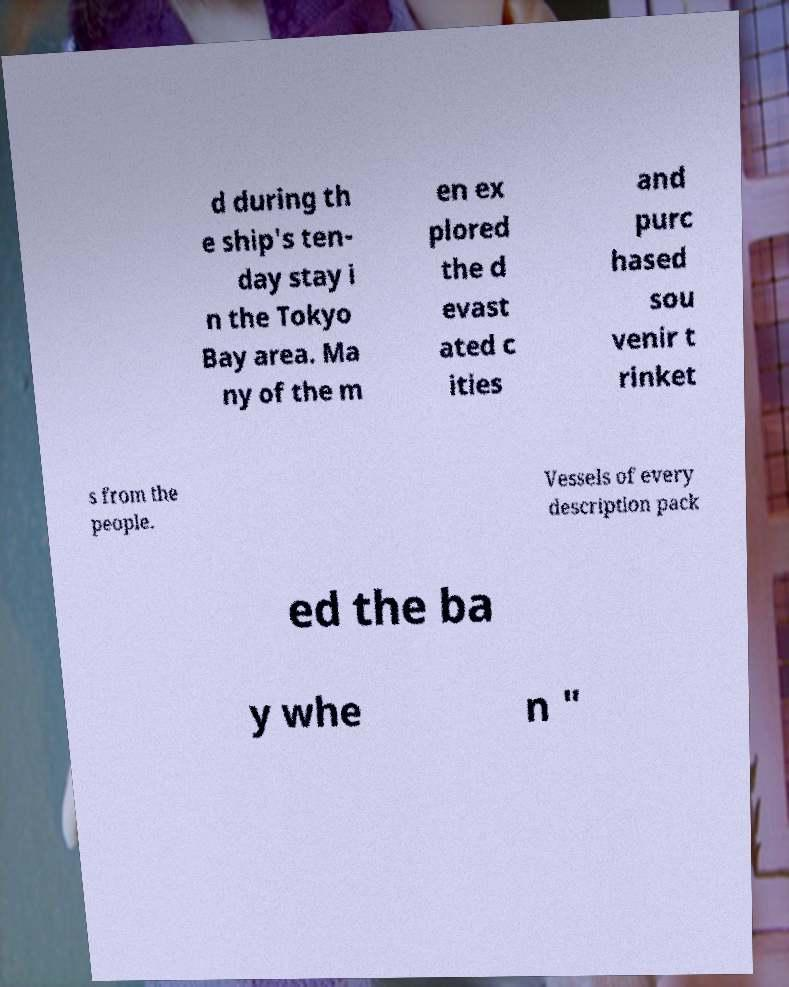Can you accurately transcribe the text from the provided image for me? d during th e ship's ten- day stay i n the Tokyo Bay area. Ma ny of the m en ex plored the d evast ated c ities and purc hased sou venir t rinket s from the people. Vessels of every description pack ed the ba y whe n " 